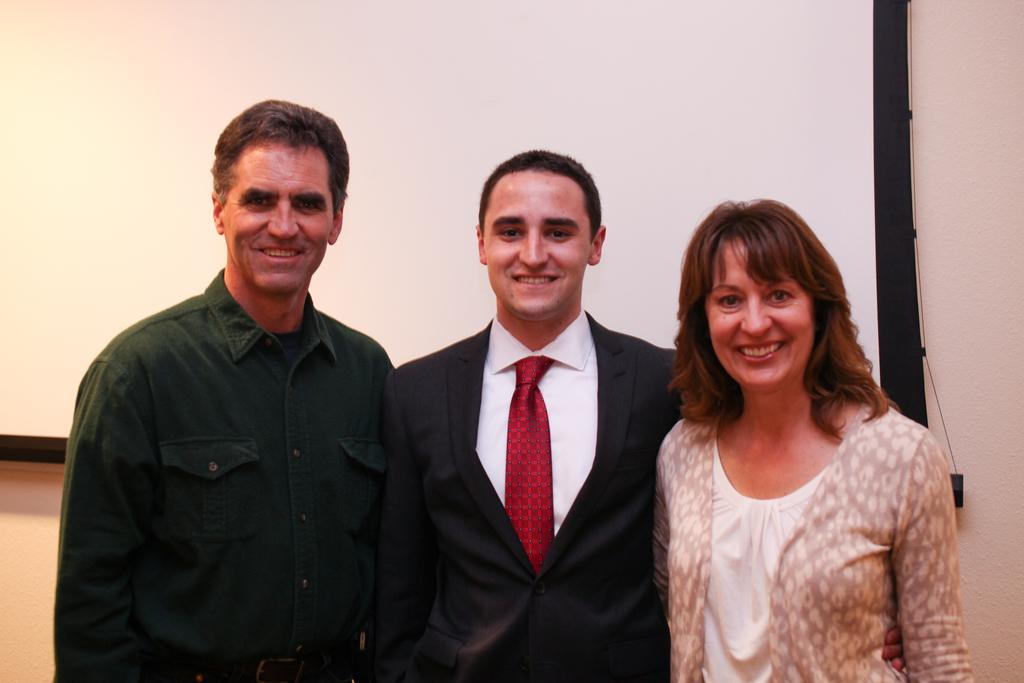How many people are in the image? There are three persons in the image. What are the persons doing in the image? The persons are posing for a camera. What expressions do the persons have in the image? The persons are smiling in the image. What can be seen in the background of the image? There is a wall and a screen in the background of the image. What type of ornament is hanging from the wall in the image? There is no ornament hanging from the wall in the image. How many apples are on the screen in the image? There are no apples visible on the screen in the image. 